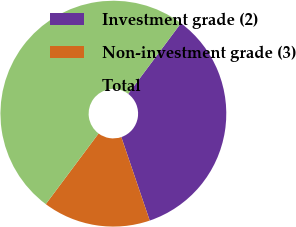<chart> <loc_0><loc_0><loc_500><loc_500><pie_chart><fcel>Investment grade (2)<fcel>Non-investment grade (3)<fcel>Total<nl><fcel>34.57%<fcel>15.43%<fcel>50.0%<nl></chart> 